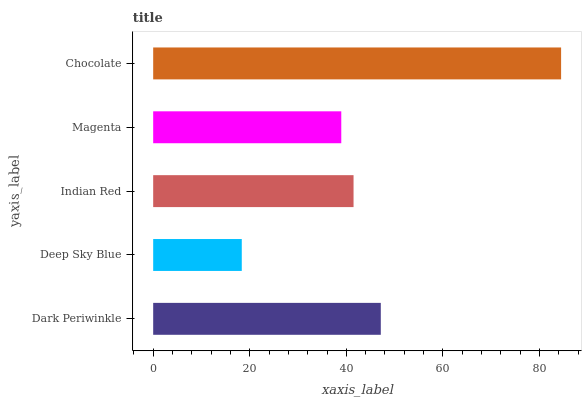Is Deep Sky Blue the minimum?
Answer yes or no. Yes. Is Chocolate the maximum?
Answer yes or no. Yes. Is Indian Red the minimum?
Answer yes or no. No. Is Indian Red the maximum?
Answer yes or no. No. Is Indian Red greater than Deep Sky Blue?
Answer yes or no. Yes. Is Deep Sky Blue less than Indian Red?
Answer yes or no. Yes. Is Deep Sky Blue greater than Indian Red?
Answer yes or no. No. Is Indian Red less than Deep Sky Blue?
Answer yes or no. No. Is Indian Red the high median?
Answer yes or no. Yes. Is Indian Red the low median?
Answer yes or no. Yes. Is Deep Sky Blue the high median?
Answer yes or no. No. Is Dark Periwinkle the low median?
Answer yes or no. No. 